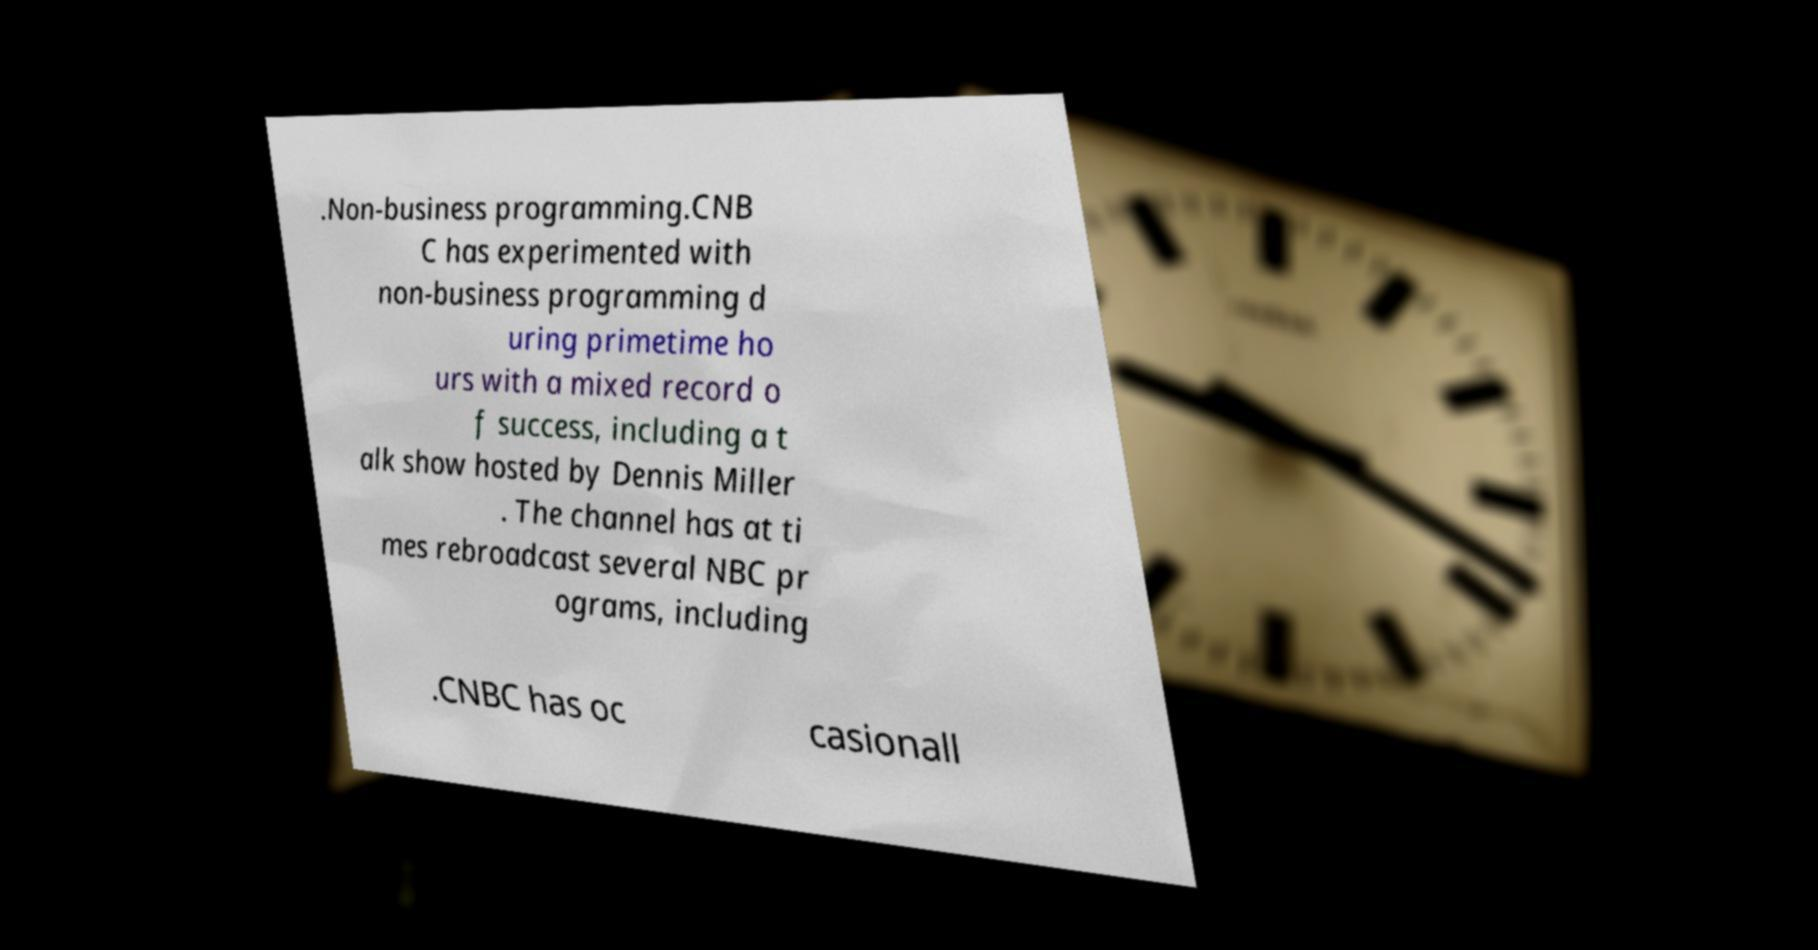Please identify and transcribe the text found in this image. .Non-business programming.CNB C has experimented with non-business programming d uring primetime ho urs with a mixed record o f success, including a t alk show hosted by Dennis Miller . The channel has at ti mes rebroadcast several NBC pr ograms, including .CNBC has oc casionall 